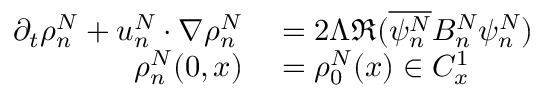Convert formula to latex. <formula><loc_0><loc_0><loc_500><loc_500>\begin{array} { r l } { \partial _ { t } \rho _ { n } ^ { N } + u _ { n } ^ { N } \cdot \nabla \rho _ { n } ^ { N } } & = 2 \Lambda \Re ( \overline { { \psi _ { n } ^ { N } } } B _ { n } ^ { N } \psi _ { n } ^ { N } ) } \\ { \rho _ { n } ^ { N } ( 0 , x ) } & = \rho _ { 0 } ^ { N } ( x ) \in C _ { x } ^ { 1 } } \end{array}</formula> 